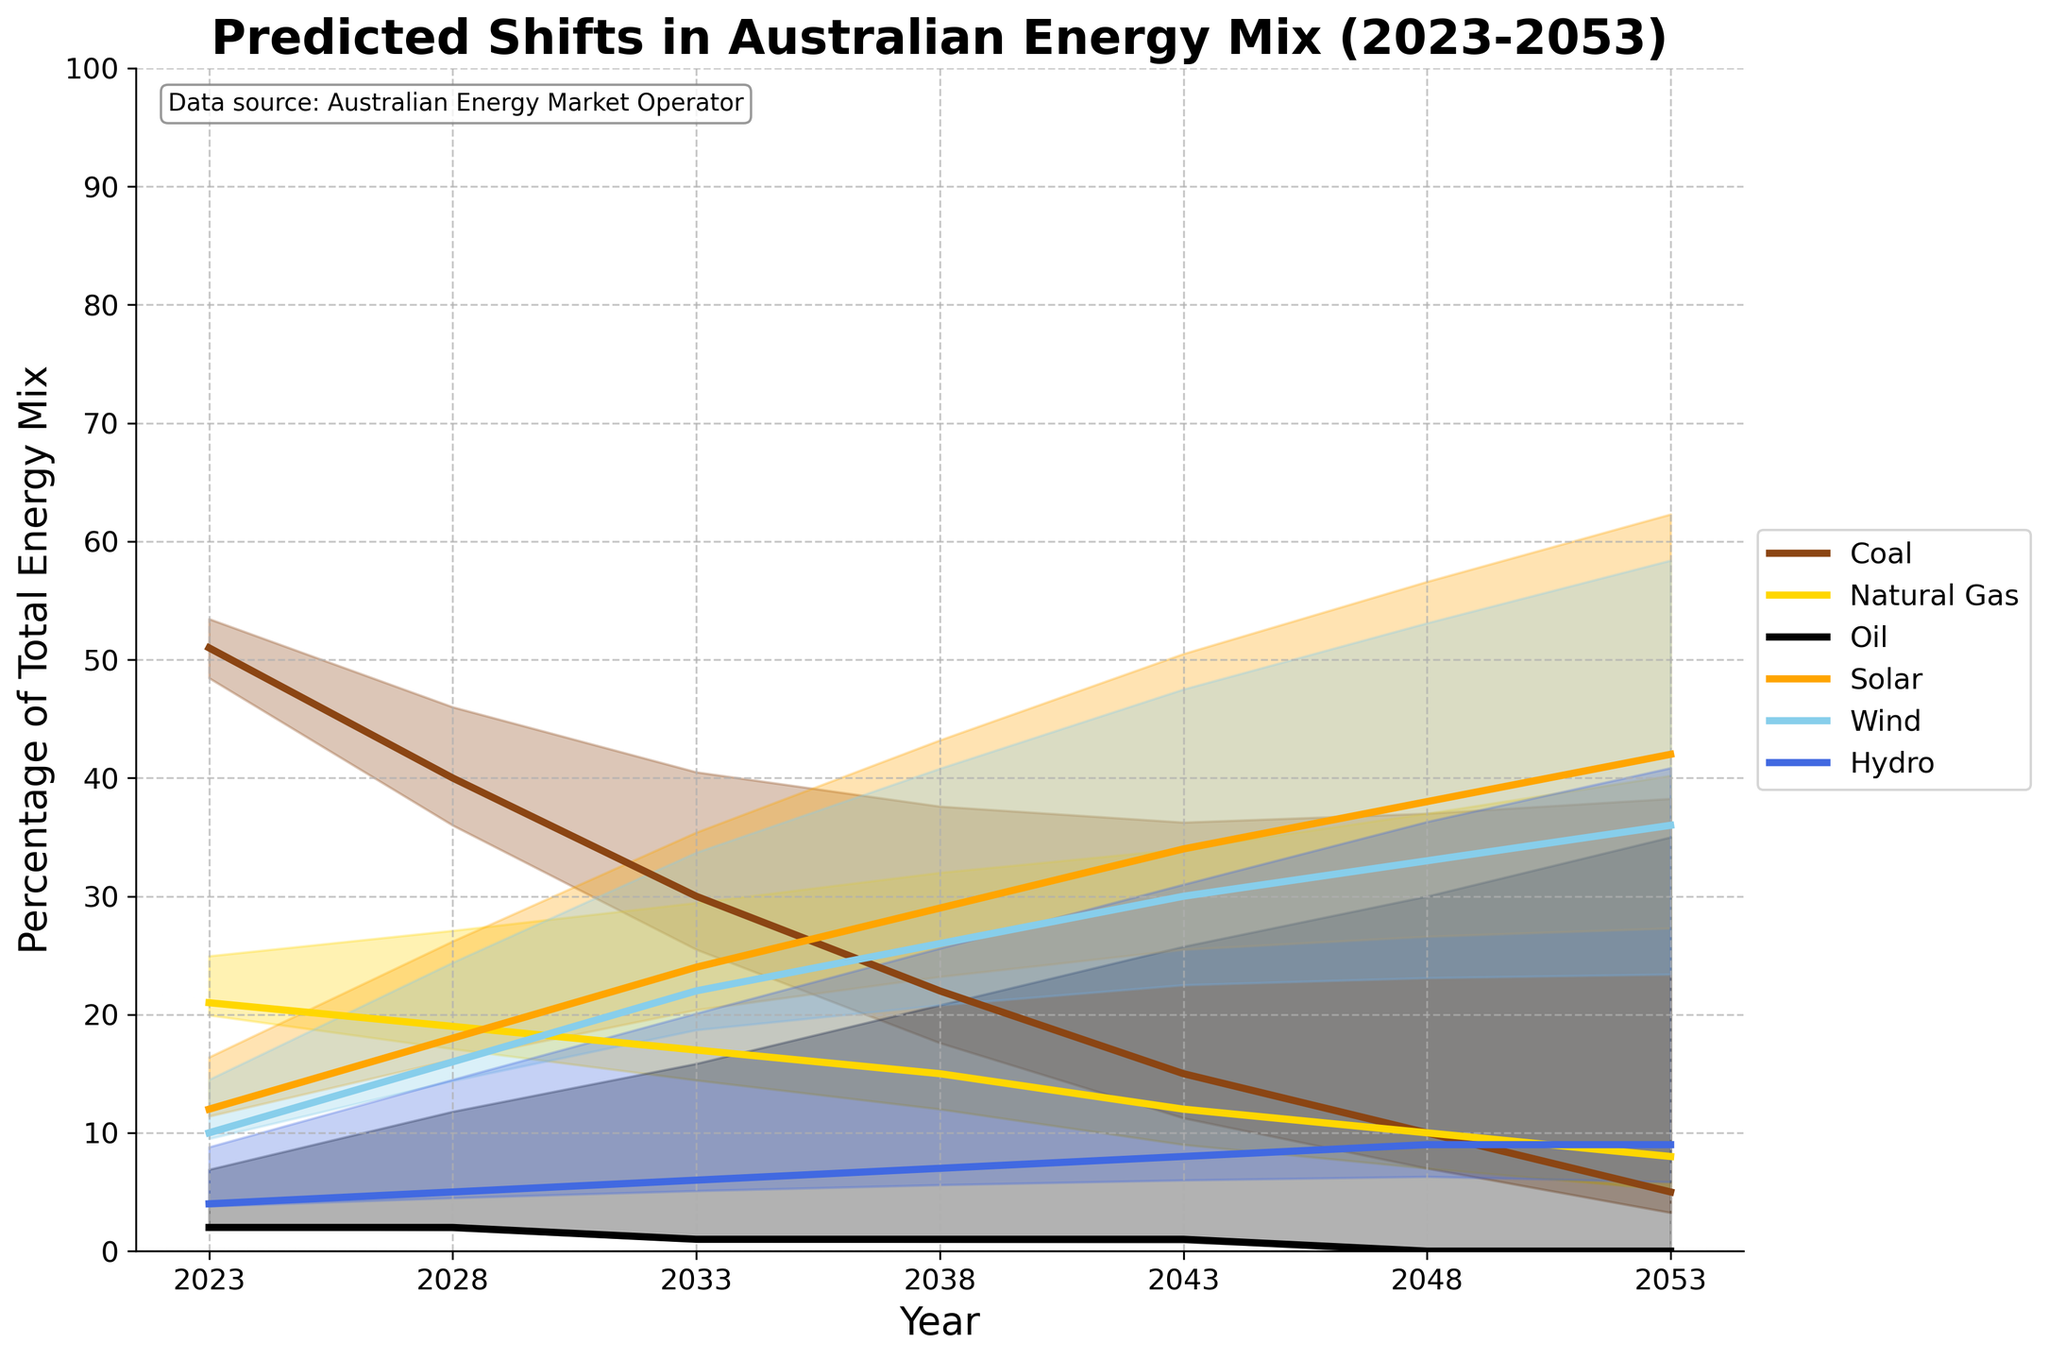What is the title of the figure? The title is displayed at the top of the figure and reads "Predicted Shifts in Australian Energy Mix (2023-2053)".
Answer: Predicted Shifts in Australian Energy Mix (2023-2053) What is the expected percentage of Coal in Australia's energy mix by 2053? The line for Coal shows that it ends at approximately 5% in the year 2053.
Answer: 5% By how much is the percentage of Solar expected to increase from 2023 to 2053? In 2023, Solar is at 12%. In 2053, it is predicted to be at 42%. The increase is 42% - 12% = 30%.
Answer: 30% Which energy source is predicted to have the largest percentage in the energy mix by 2053? The highest percentage in 2053 belongs to Solar, which reaches 42%.
Answer: Solar How does the confidence range for Natural Gas in 2028 compare to its confidence range in 2033? The confidence range for Natural Gas in 2028 ranges from approximately 12.6% to 25.4% (19% ± 1.9% * 100). In 2033, it ranges from approximately 9.55% to 24.45% (17% ± 2.55% * 100). The range widens slightly in 2033.
Answer: Wider in 2033 What is the confidence interval for Wind in 2043? The confidence for Wind in 2043 is 75%. The values range from approximately 7.5% (variance of 25% over actual 30%) below to 52.5% (variance of 25% remaining over 30%) above 30%. Thus, the interval is from 22.5% to 37.5%.
Answer: 22.5% to 37.5% What is the percentage prediction for Hydro in 2038? The line representing Hydro is at the value of 7% in the year 2038.
Answer: 7% How many energy sources are shown in the figure? By looking at the legend and the lines, there are six energy sources: Coal, Natural Gas, Oil, Solar, Wind, and Hydro.
Answer: 6 Which year displays the largest predicted proportion for Coal? The line representing Coal is highest at the start, which corresponds to the year 2023, with a value of approximately 51%.
Answer: 2023 